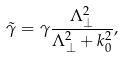Convert formula to latex. <formula><loc_0><loc_0><loc_500><loc_500>\tilde { \gamma } & = \gamma \frac { \Lambda _ { \perp } ^ { 2 } } { \Lambda _ { \perp } ^ { 2 } + k _ { 0 } ^ { 2 } } ,</formula> 